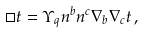Convert formula to latex. <formula><loc_0><loc_0><loc_500><loc_500>\Box t = \Upsilon _ { q } n ^ { b } n ^ { c } \nabla _ { b } \nabla _ { c } t \, ,</formula> 